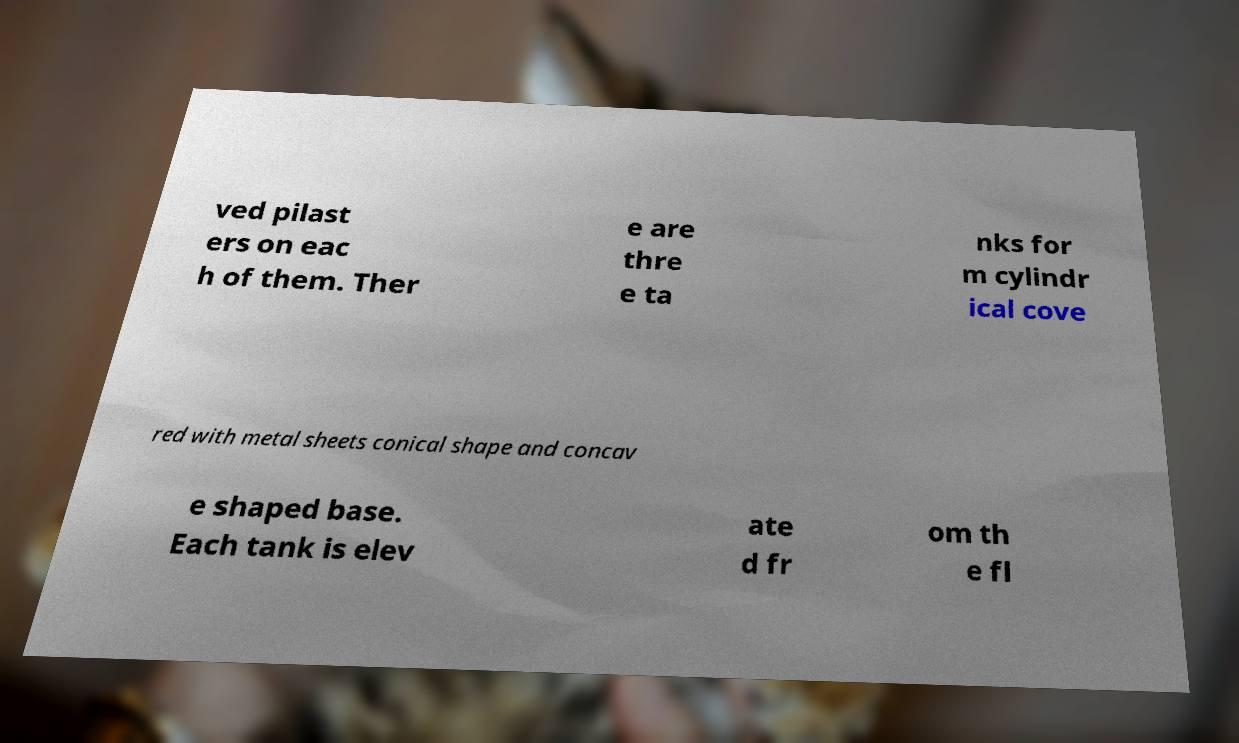I need the written content from this picture converted into text. Can you do that? ved pilast ers on eac h of them. Ther e are thre e ta nks for m cylindr ical cove red with metal sheets conical shape and concav e shaped base. Each tank is elev ate d fr om th e fl 